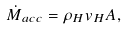<formula> <loc_0><loc_0><loc_500><loc_500>\dot { M } _ { a c c } = \rho _ { H } v _ { H } A ,</formula> 